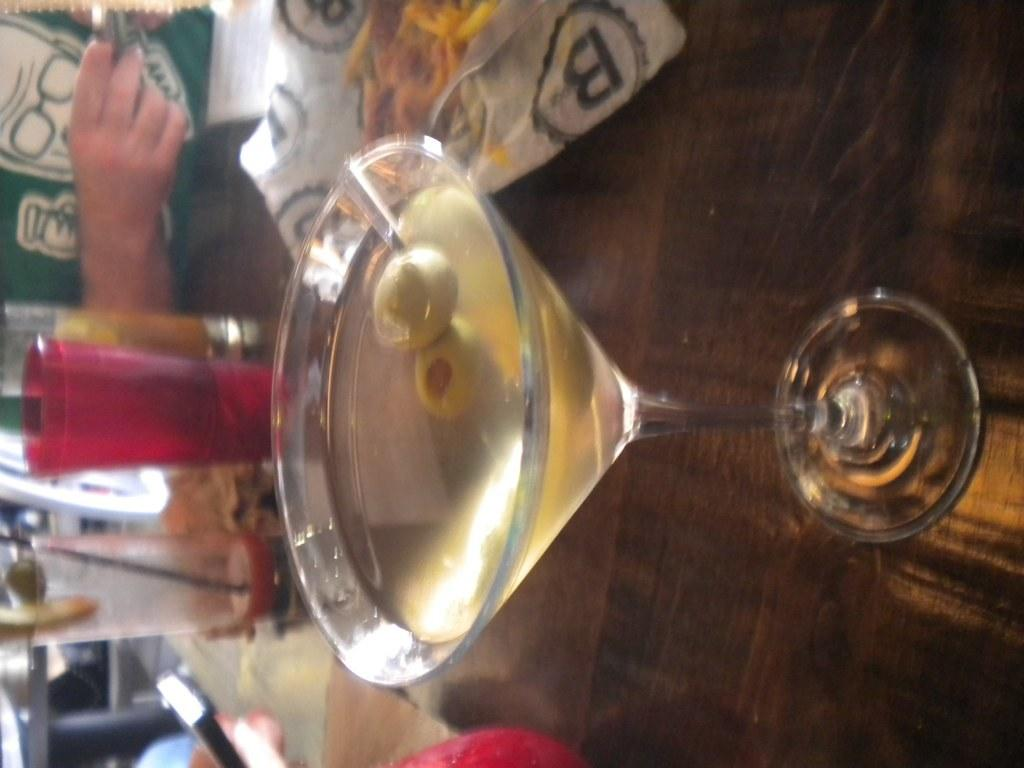What is contained in the glass that is visible in the image? There is a drink in the glass in the image. What else can be seen in the image besides the glass with a drink? There is a packet and glasses visible in the image. Can you describe the person in the image? There is a person in the image, but no specific details about their appearance or actions are provided. What type of plantation is shown in the image? There is no plantation present in the image. What kind of show is the person in the image attending? There is no indication of a show or event in the image. 